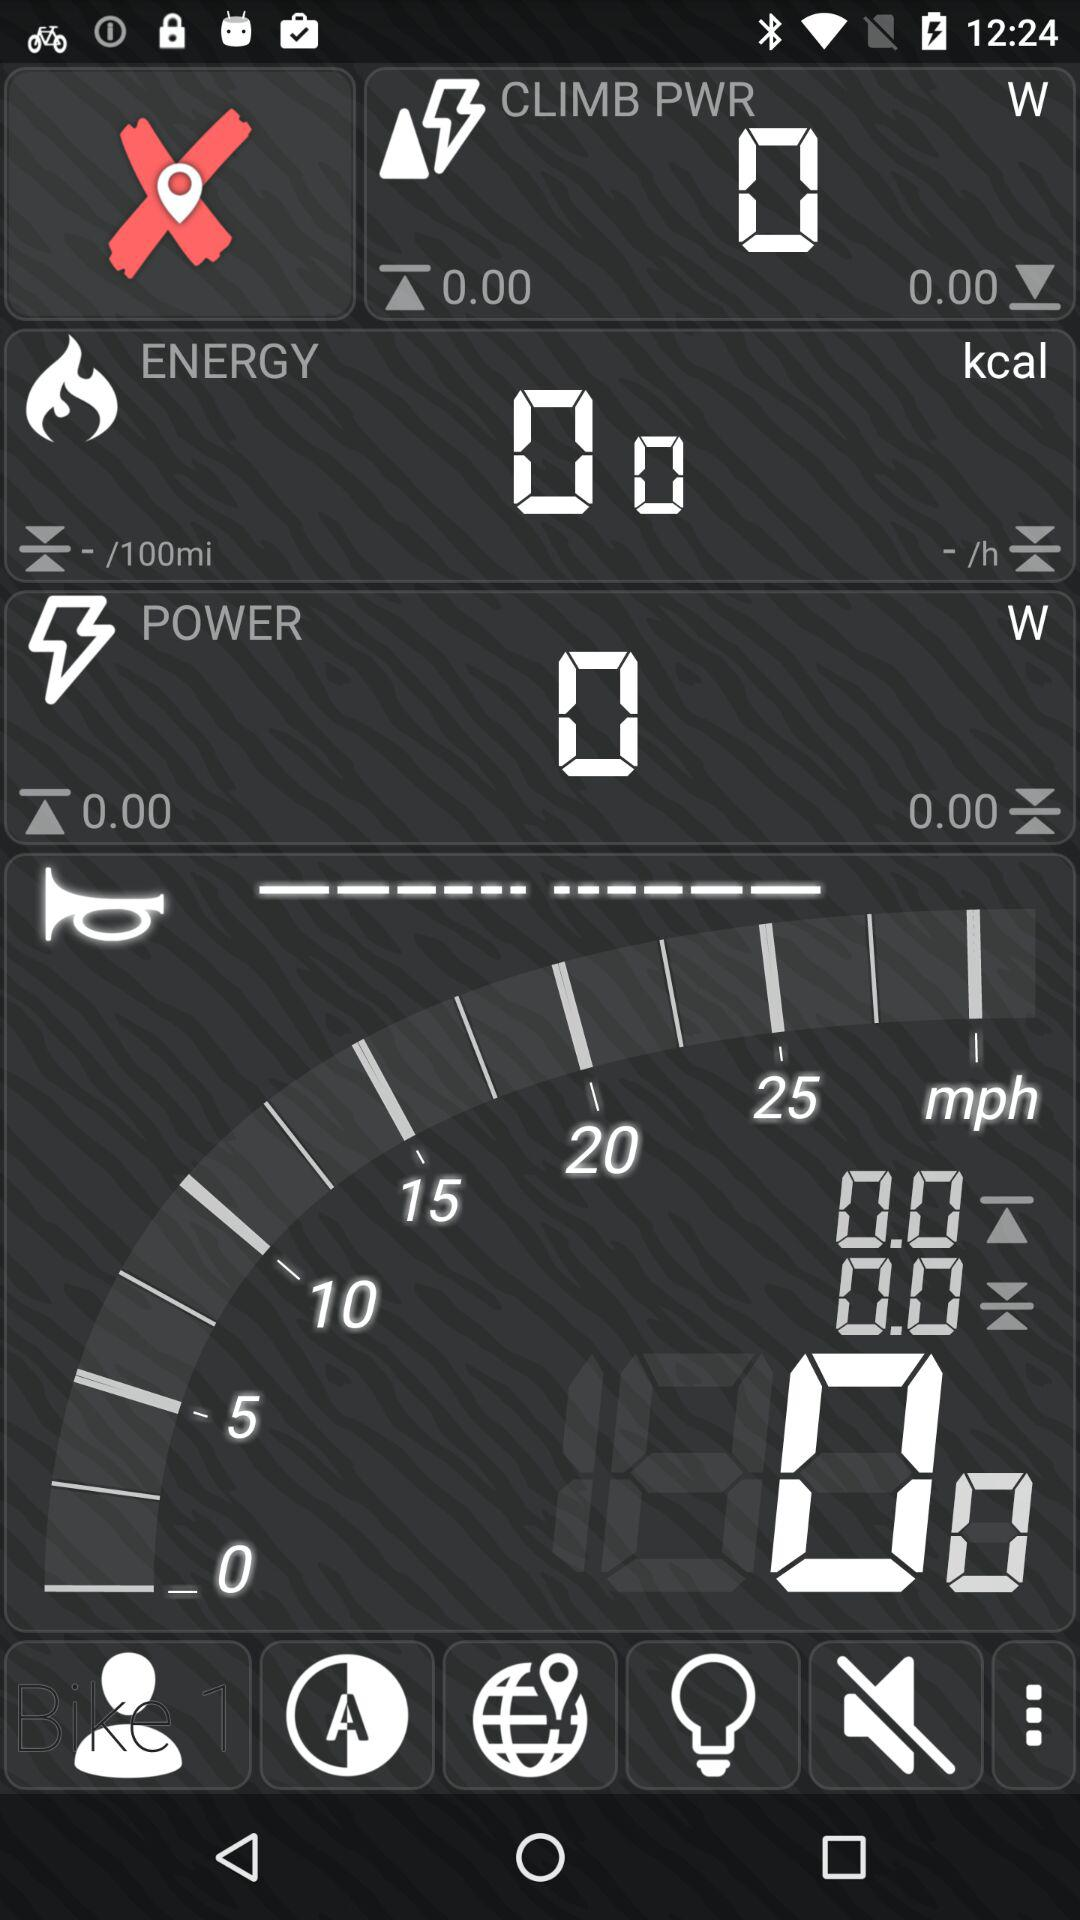What is the energy in kcal? The energy in kcal is 0. 